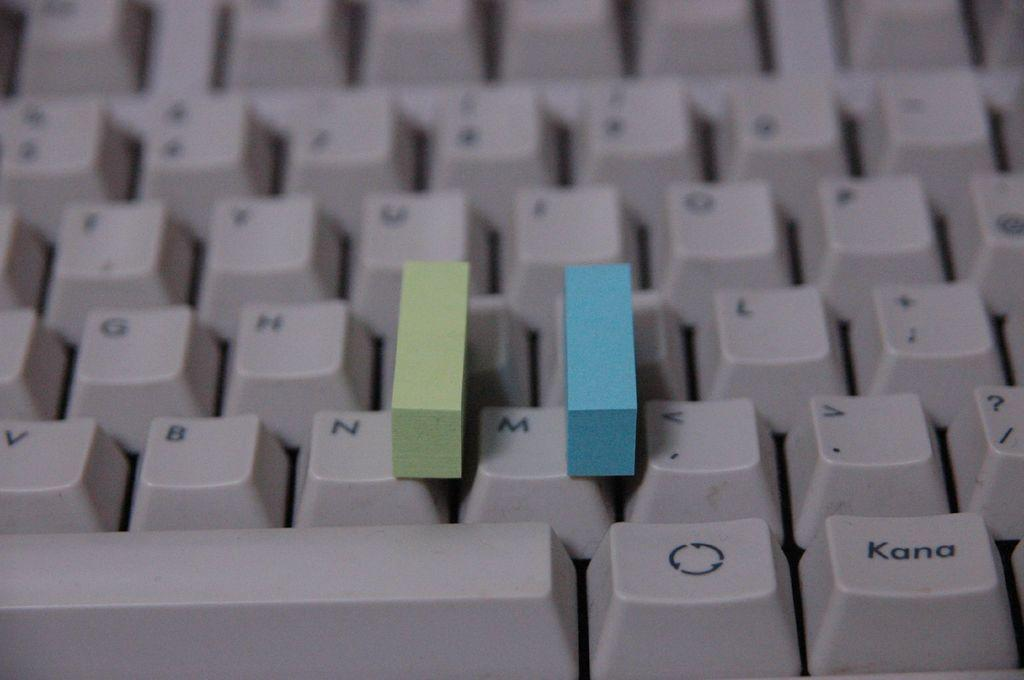<image>
Write a terse but informative summary of the picture. Part of a keyboard with a green small rectangle item to the right of the N and a blue one to the right of the M. 